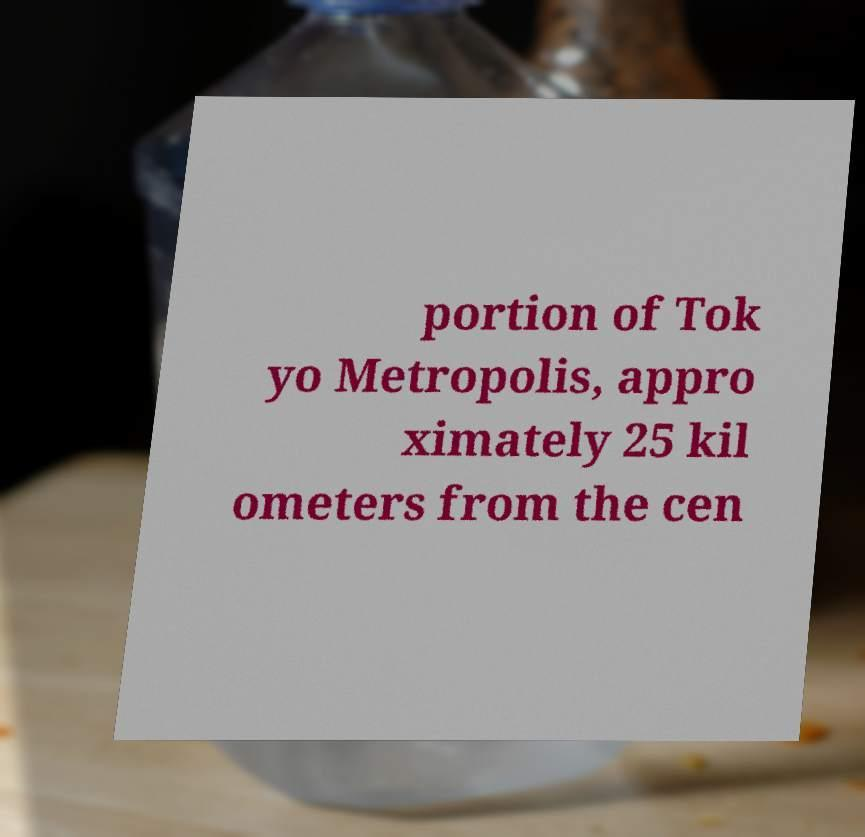Can you accurately transcribe the text from the provided image for me? portion of Tok yo Metropolis, appro ximately 25 kil ometers from the cen 